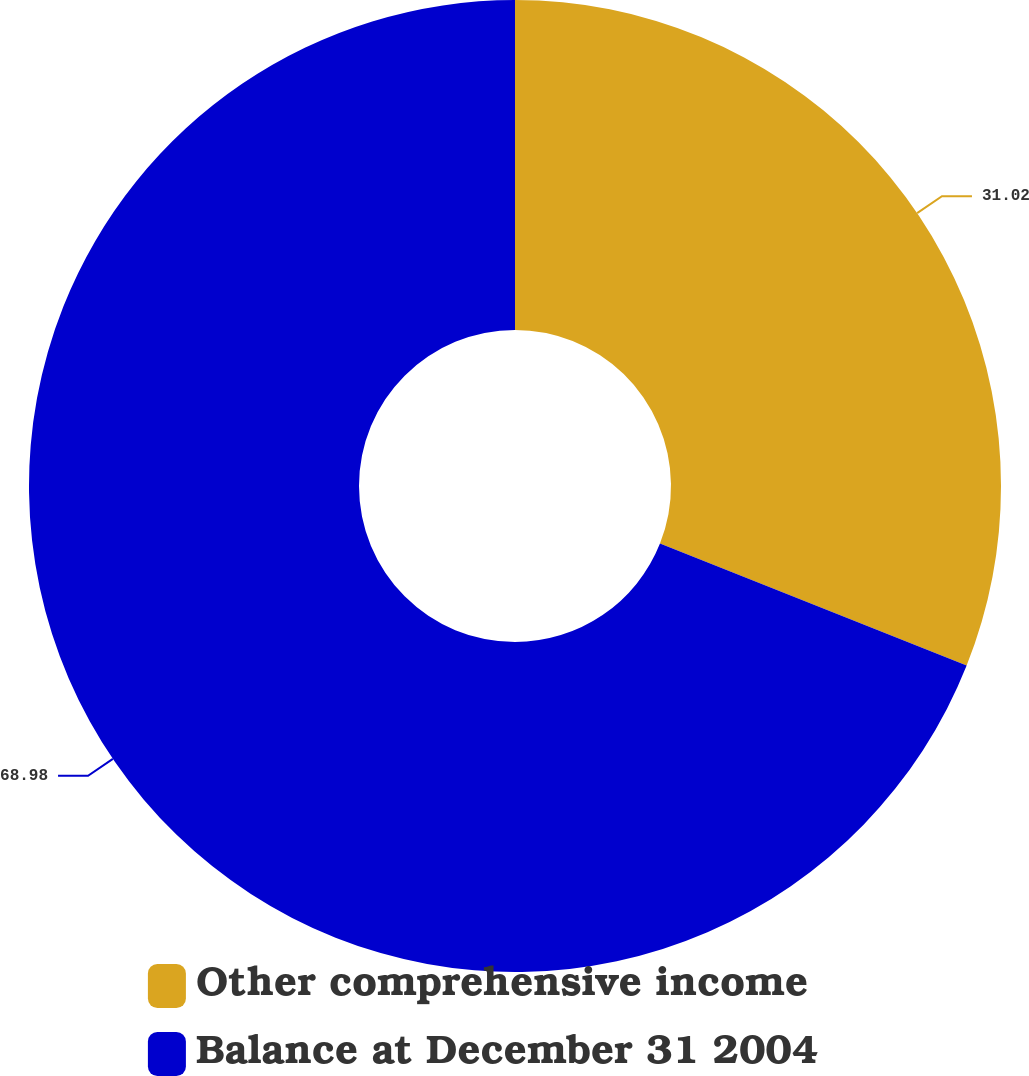Convert chart. <chart><loc_0><loc_0><loc_500><loc_500><pie_chart><fcel>Other comprehensive income<fcel>Balance at December 31 2004<nl><fcel>31.02%<fcel>68.98%<nl></chart> 